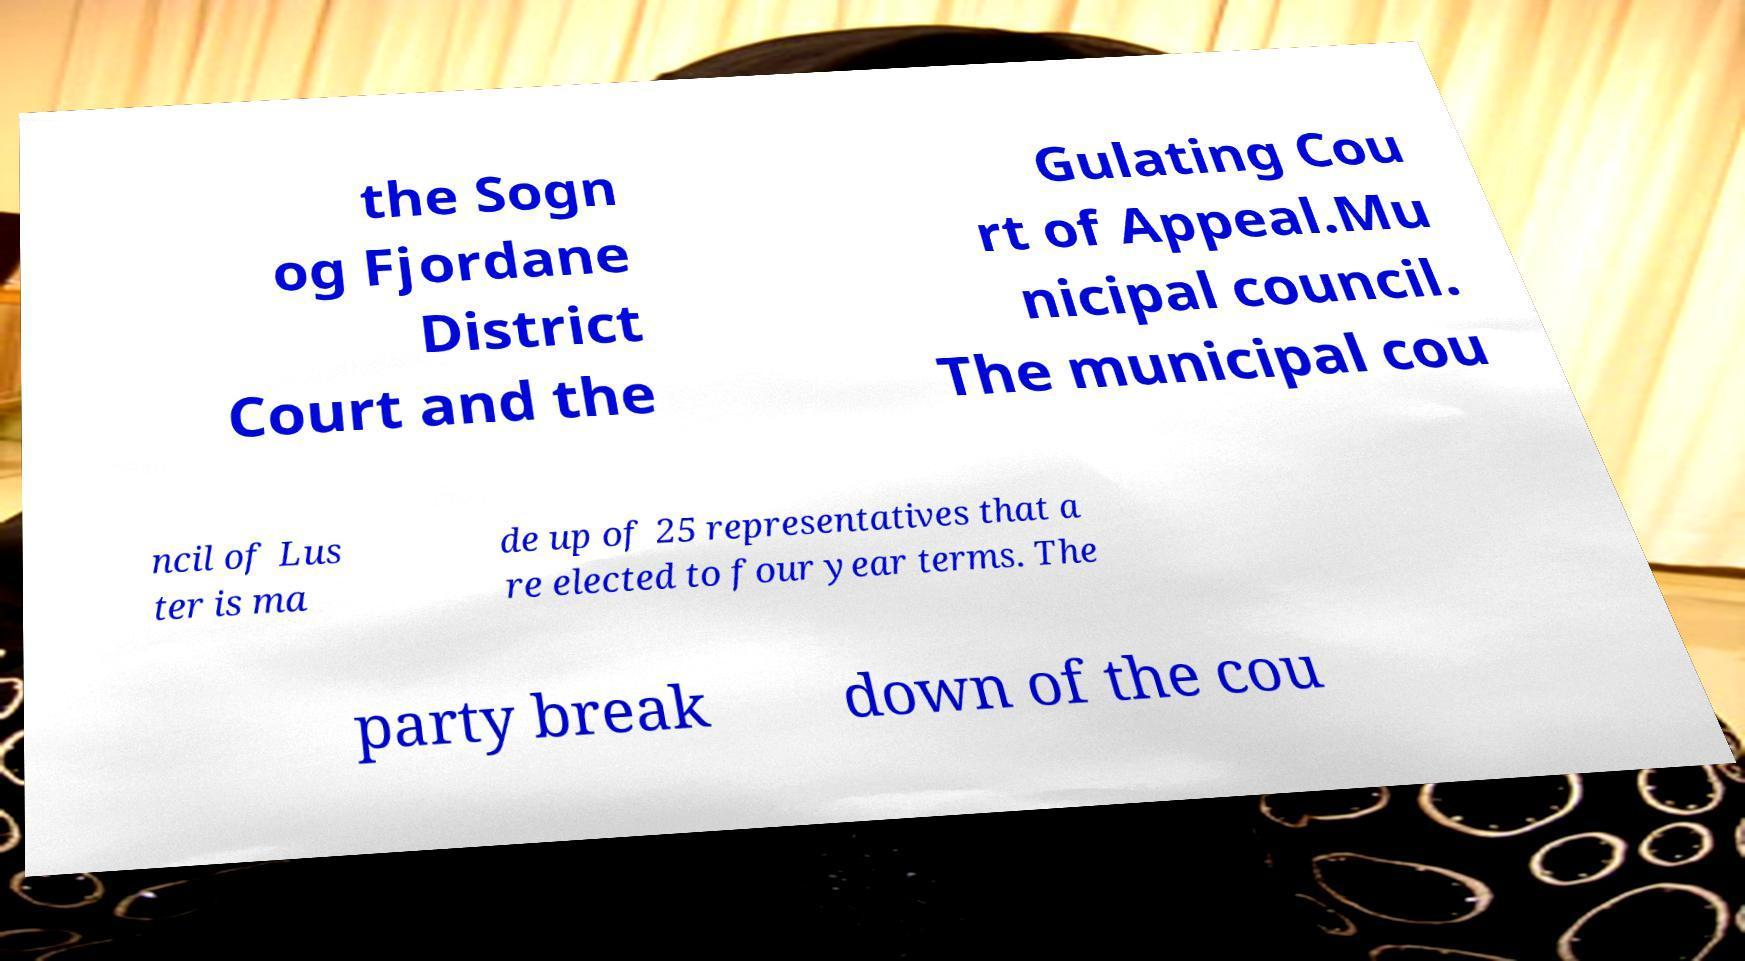There's text embedded in this image that I need extracted. Can you transcribe it verbatim? the Sogn og Fjordane District Court and the Gulating Cou rt of Appeal.Mu nicipal council. The municipal cou ncil of Lus ter is ma de up of 25 representatives that a re elected to four year terms. The party break down of the cou 